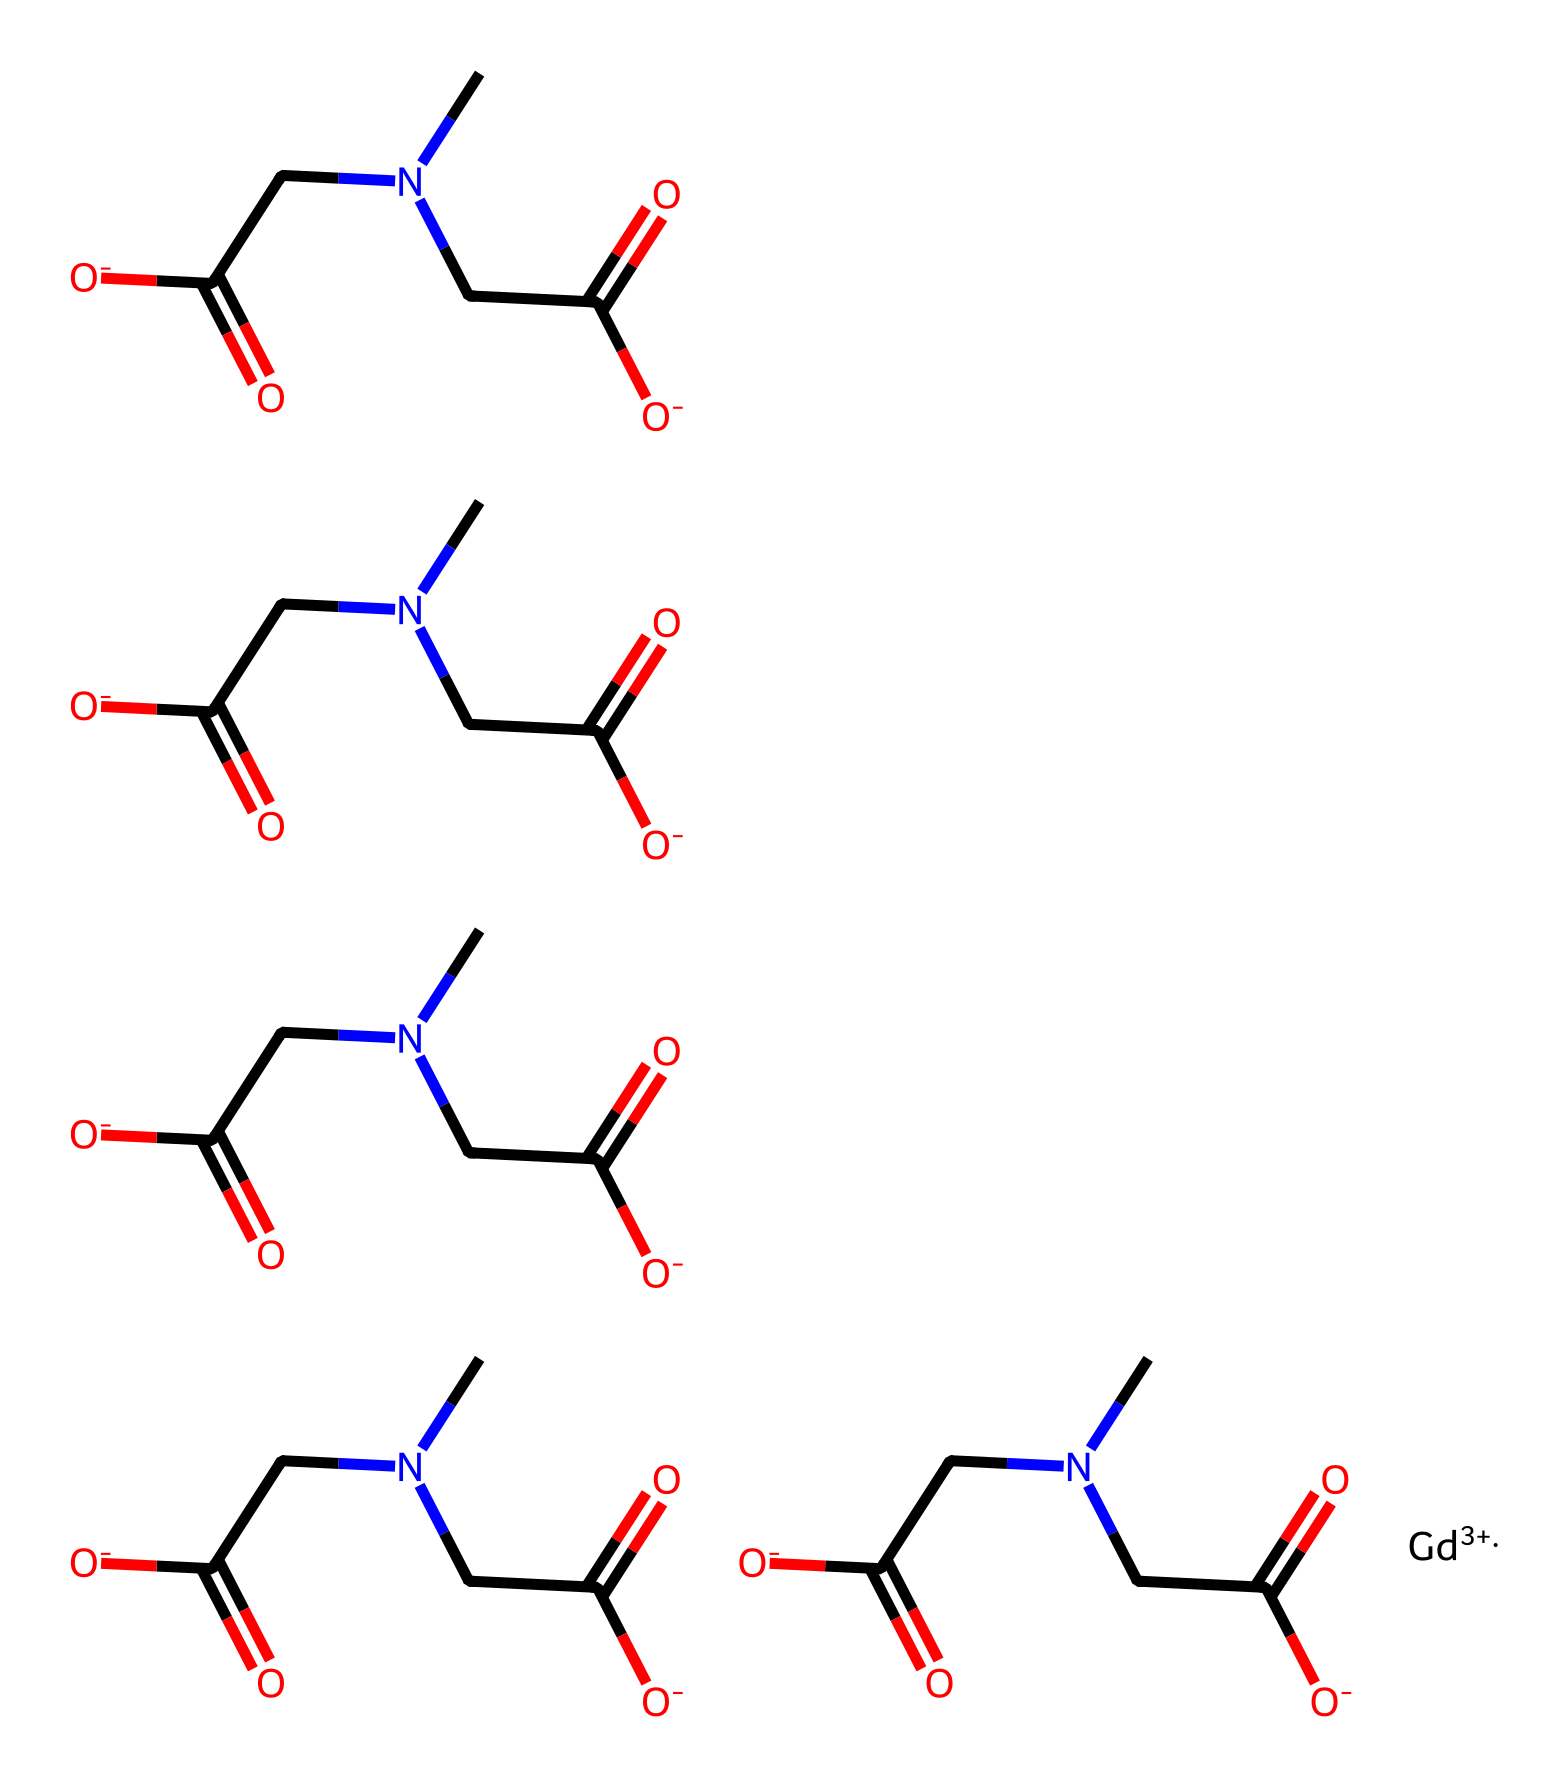What is the central metal ion in this contrast agent? The SMILES notation indicates the presence of a gadolinium ion, represented as [Gd+3], suggesting that it is the central metal ion in this complex.
Answer: gadolinium How many carbon atoms are present in this structure? By analyzing the SMILES string, we can count the instances of 'C', which leads to a total of 20 carbon atoms.
Answer: 20 What type of functional groups are present in this molecule? The presence of "CC(=O)[O-]" indicates the existence of carboxylate groups (or carboxylic acid derivatives), which consist of a carbonyl and a hydroxyl group, typical for gadolinium contrast agents.
Answer: carboxylate How many ethylamine linkers are found in the structure? Each "CN" portion represents an ethylamine linkage, and counting these reveals that there are five such linkers in the molecule.
Answer: 5 What charge does the gadolinium ion carry in this complex? The notation "[Gd+3]" directly indicates that the gadolinium ion has a +3 charge, which is important for its interaction in MRI imaging.
Answer: +3 Are there any spheres of coordination associated with the gadolinium ion? The multiple carboxylate groups coordinated to the gadolinium ion imply that it has a coordination sphere formed by these groups, which is typical of chelating agents in MRI contrast.
Answer: yes 